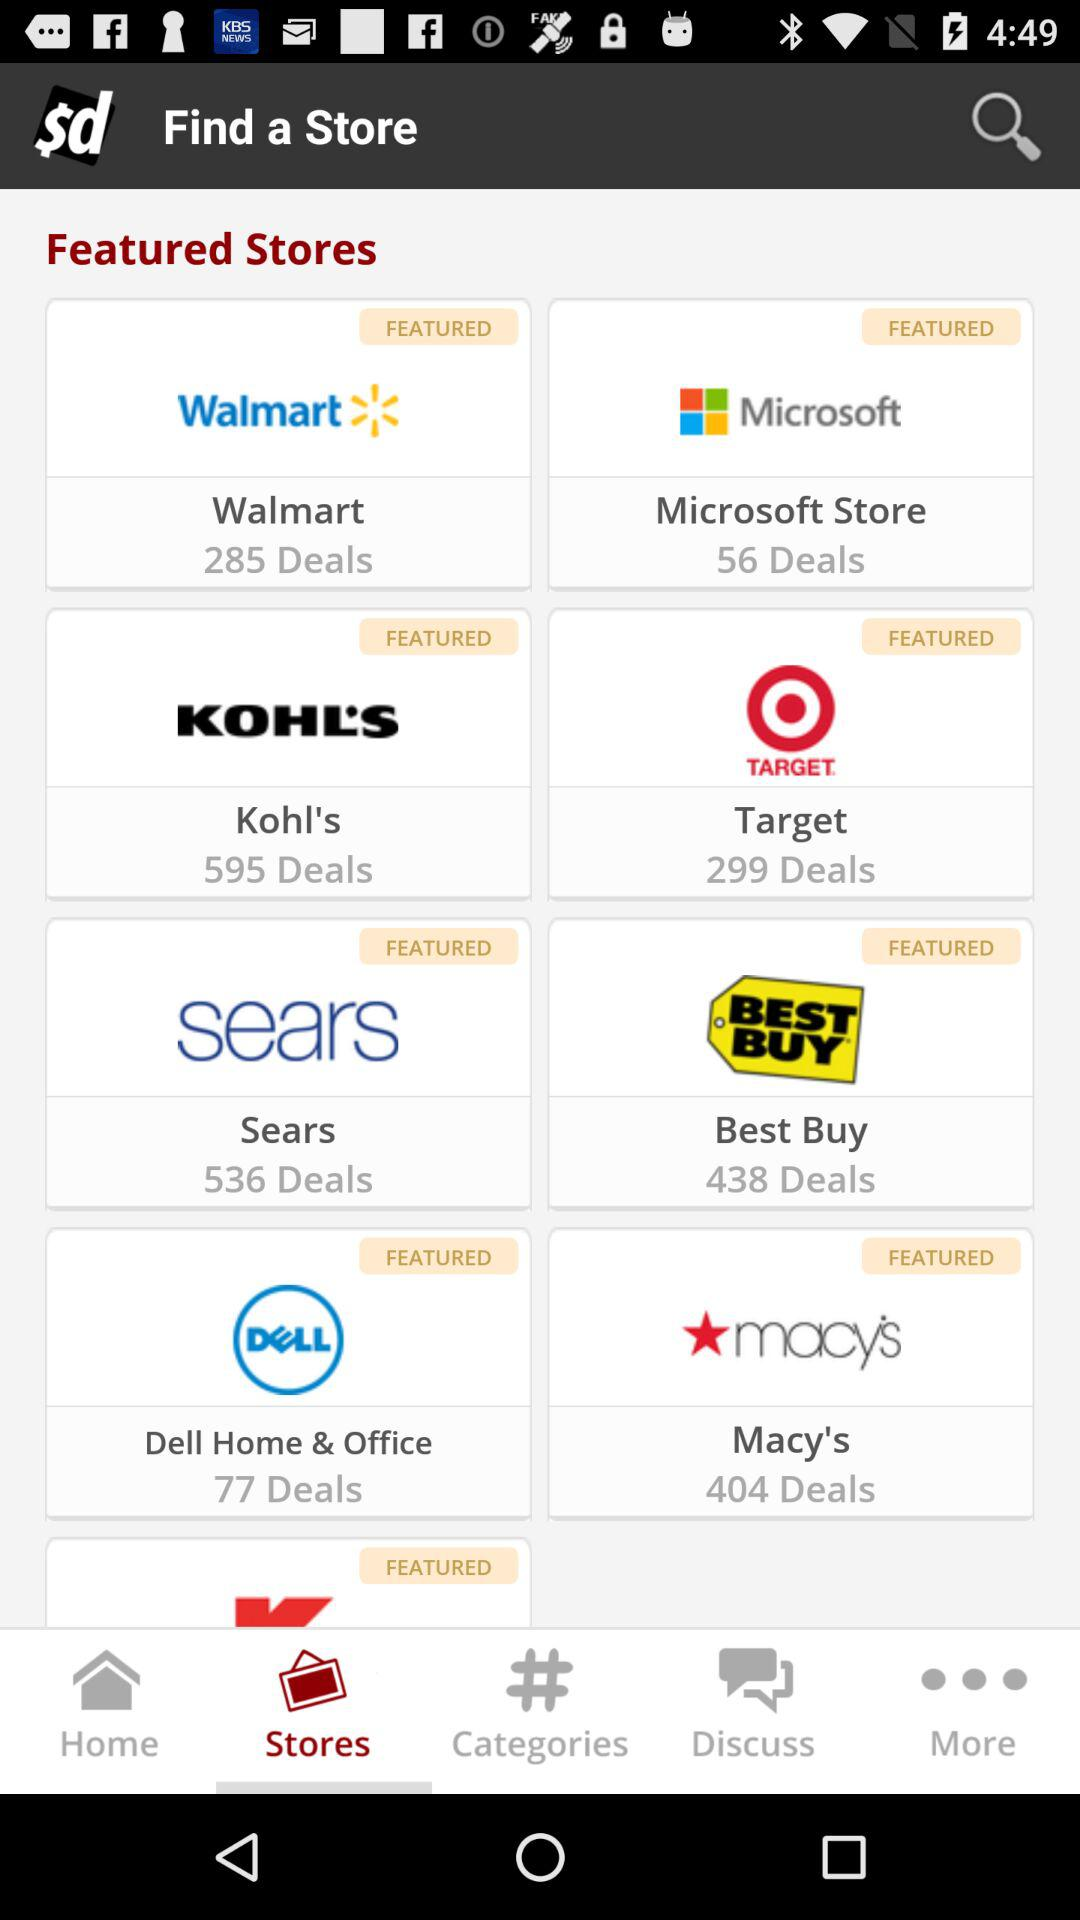Which tab is selected? The selected tab is "Stores". 